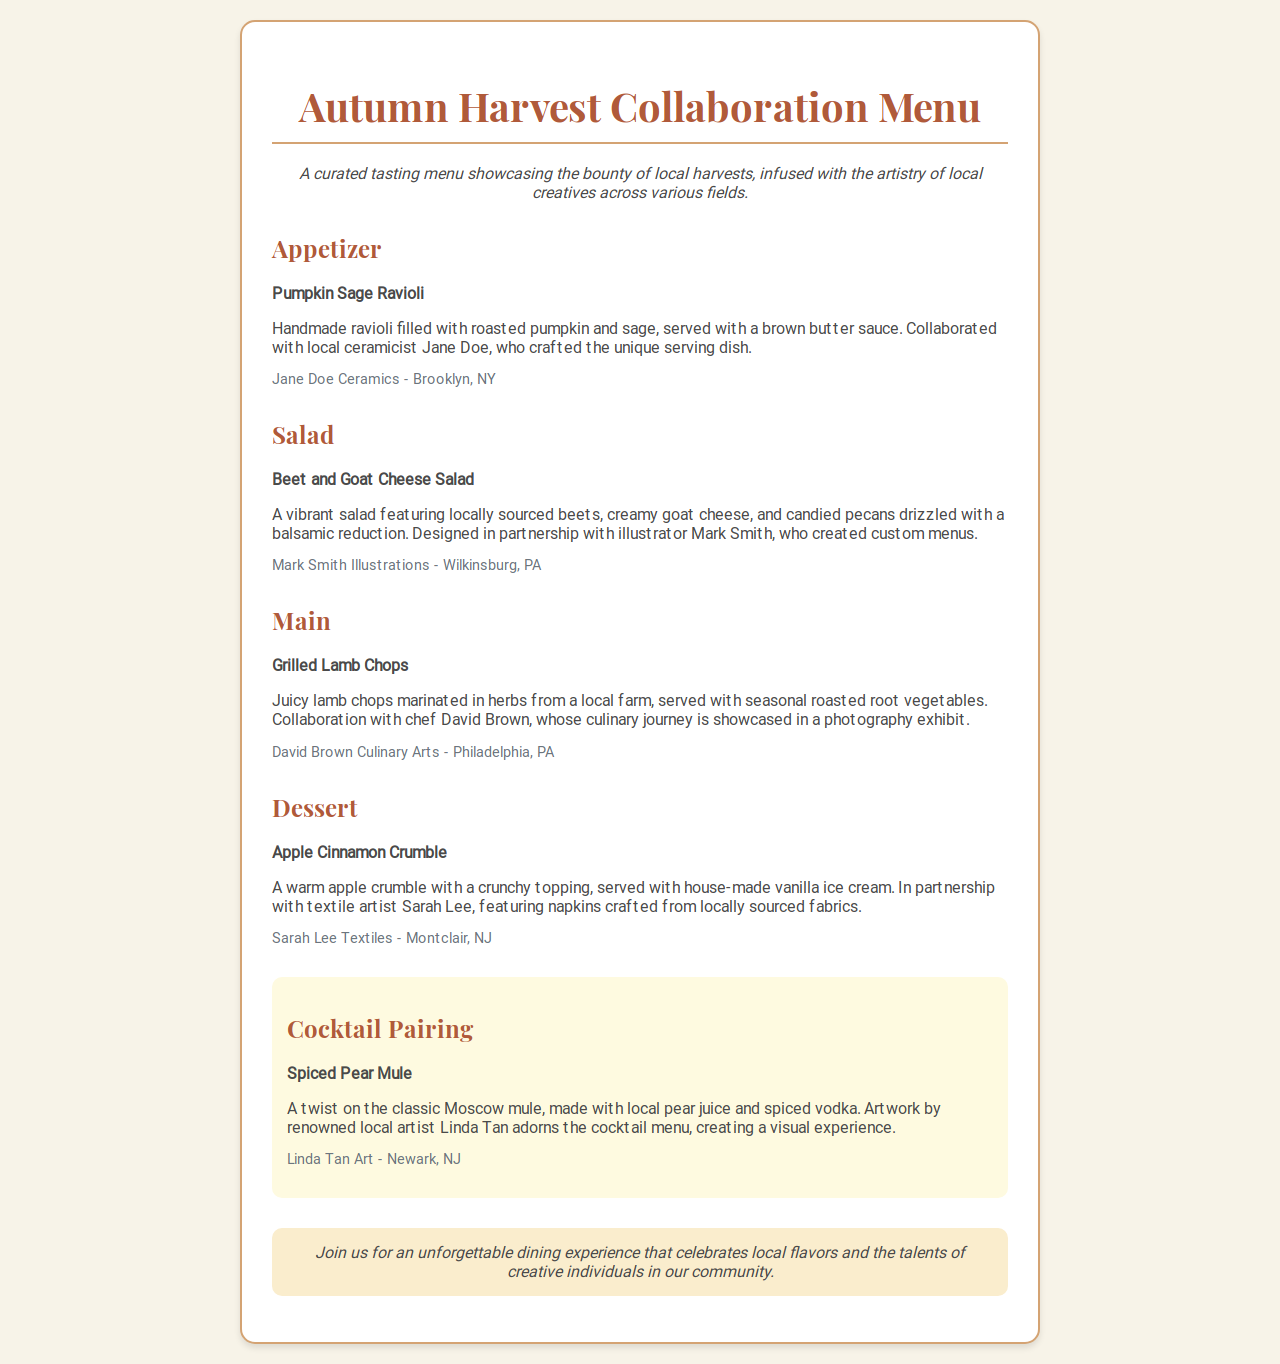What is the name of the appetizer? The appetizer is identified as "Pumpkin Sage Ravioli".
Answer: Pumpkin Sage Ravioli Who collaborated on the salad dish? The salad was created in partnership with illustrator Mark Smith, who designed custom menus.
Answer: Mark Smith What is the main course featured in the menu? The main course is highlighted as "Grilled Lamb Chops".
Answer: Grilled Lamb Chops Which local creative provided ceramics for the first dish? The ceramicist who crafted the unique serving dish for the appetizer is Jane Doe.
Answer: Jane Doe What type of dessert is included in the menu? The dessert is "Apple Cinnamon Crumble" according to the dessert section.
Answer: Apple Cinnamon Crumble How many courses are listed on the menu? The menu consists of four main courses: appetizer, salad, main, and dessert.
Answer: Four What is the name of the cocktail pairing? The cocktail pairing is titled "Spiced Pear Mule".
Answer: Spiced Pear Mule Which local artist contributed artwork to the cocktail menu? The local artist who provided artwork for the cocktail menu is Linda Tan.
Answer: Linda Tan What unique feature does the dessert have? The dessert is served with house-made vanilla ice cream, adding a special twist to it.
Answer: House-made vanilla ice cream 